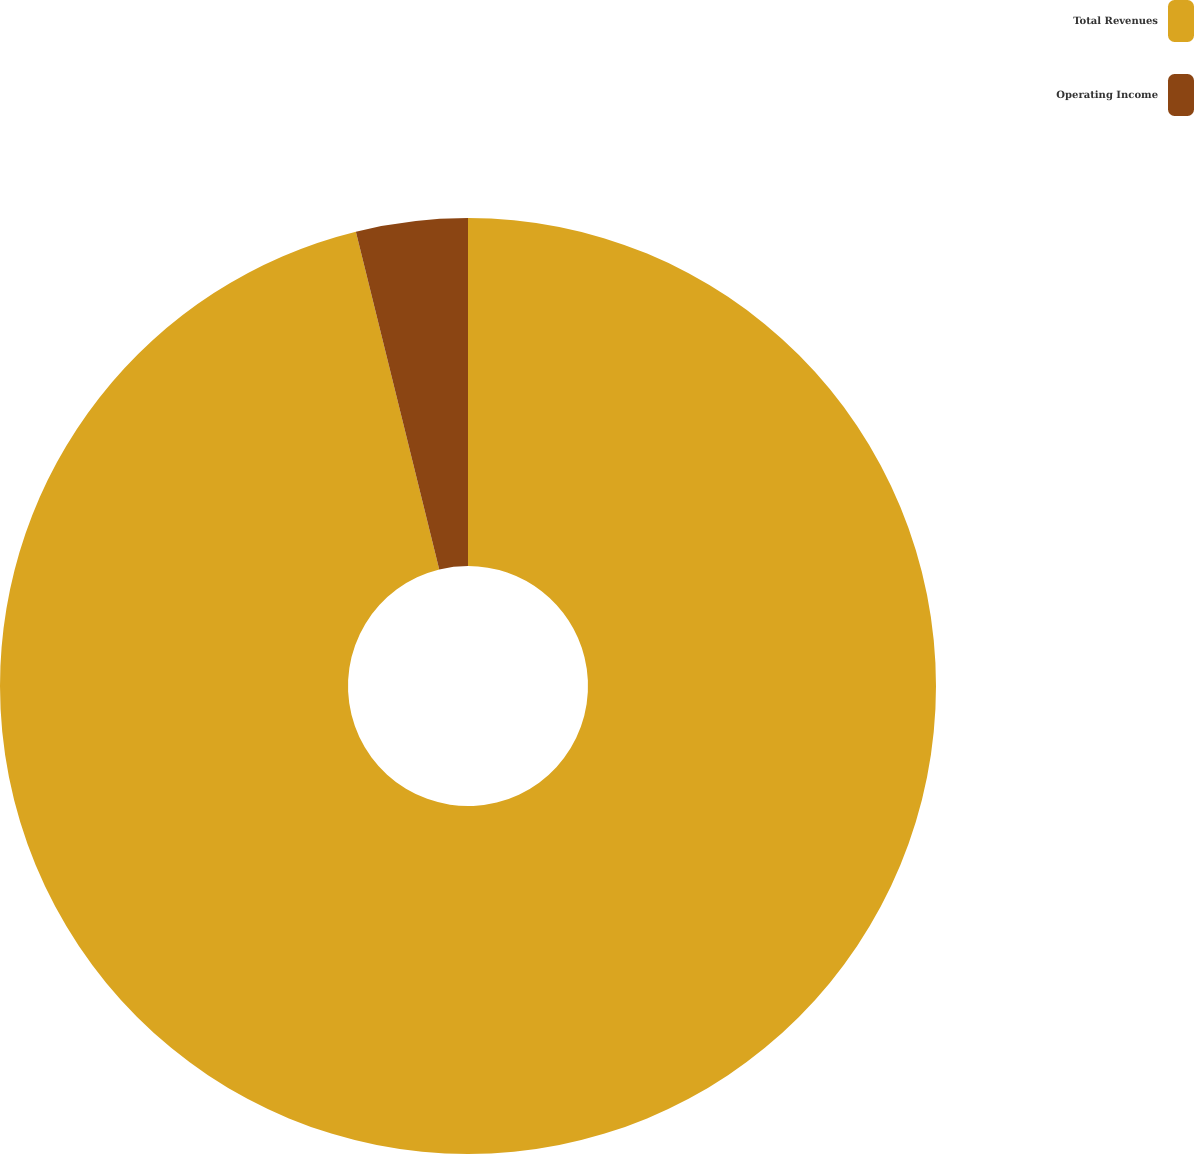Convert chart. <chart><loc_0><loc_0><loc_500><loc_500><pie_chart><fcel>Total Revenues<fcel>Operating Income<nl><fcel>96.15%<fcel>3.85%<nl></chart> 